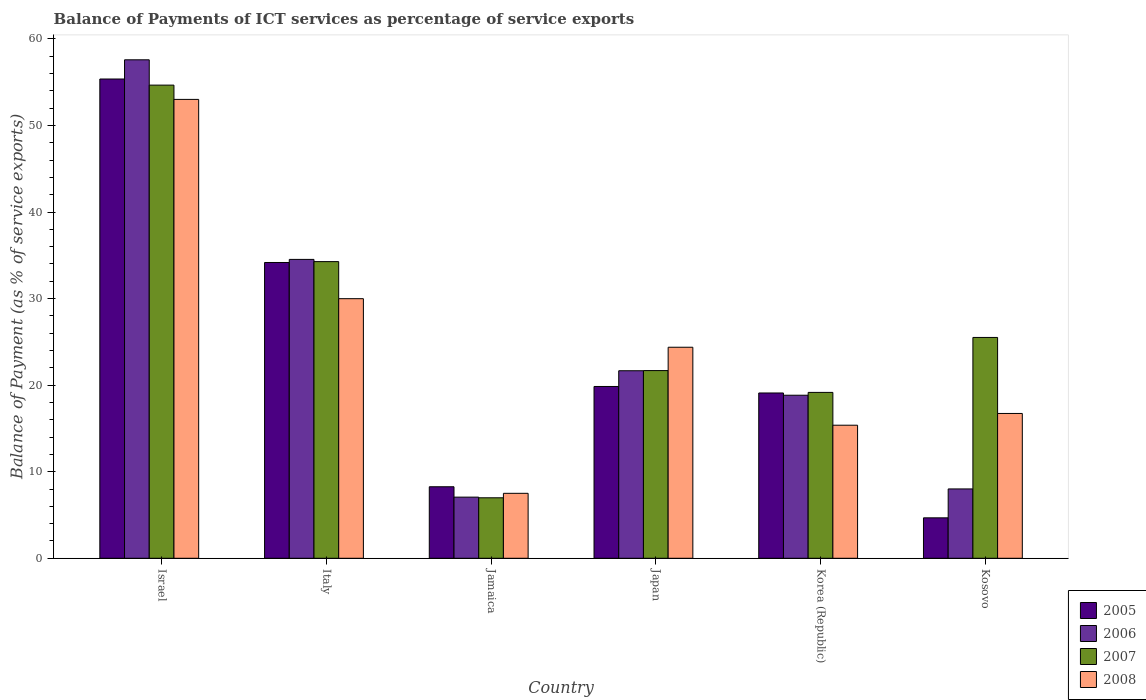How many groups of bars are there?
Keep it short and to the point. 6. Are the number of bars on each tick of the X-axis equal?
Your response must be concise. Yes. How many bars are there on the 1st tick from the left?
Offer a very short reply. 4. What is the label of the 6th group of bars from the left?
Provide a succinct answer. Kosovo. In how many cases, is the number of bars for a given country not equal to the number of legend labels?
Give a very brief answer. 0. What is the balance of payments of ICT services in 2005 in Kosovo?
Keep it short and to the point. 4.67. Across all countries, what is the maximum balance of payments of ICT services in 2005?
Your answer should be compact. 55.37. Across all countries, what is the minimum balance of payments of ICT services in 2006?
Make the answer very short. 7.06. In which country was the balance of payments of ICT services in 2007 minimum?
Provide a succinct answer. Jamaica. What is the total balance of payments of ICT services in 2006 in the graph?
Give a very brief answer. 147.7. What is the difference between the balance of payments of ICT services in 2007 in Jamaica and that in Korea (Republic)?
Give a very brief answer. -12.18. What is the difference between the balance of payments of ICT services in 2007 in Kosovo and the balance of payments of ICT services in 2006 in Korea (Republic)?
Offer a very short reply. 6.68. What is the average balance of payments of ICT services in 2008 per country?
Offer a very short reply. 24.5. What is the difference between the balance of payments of ICT services of/in 2007 and balance of payments of ICT services of/in 2006 in Italy?
Ensure brevity in your answer.  -0.26. In how many countries, is the balance of payments of ICT services in 2005 greater than 54 %?
Your answer should be compact. 1. What is the ratio of the balance of payments of ICT services in 2007 in Japan to that in Kosovo?
Your answer should be compact. 0.85. Is the difference between the balance of payments of ICT services in 2007 in Japan and Korea (Republic) greater than the difference between the balance of payments of ICT services in 2006 in Japan and Korea (Republic)?
Your response must be concise. No. What is the difference between the highest and the second highest balance of payments of ICT services in 2005?
Give a very brief answer. 14.33. What is the difference between the highest and the lowest balance of payments of ICT services in 2005?
Provide a succinct answer. 50.7. In how many countries, is the balance of payments of ICT services in 2006 greater than the average balance of payments of ICT services in 2006 taken over all countries?
Keep it short and to the point. 2. Is the sum of the balance of payments of ICT services in 2007 in Italy and Jamaica greater than the maximum balance of payments of ICT services in 2008 across all countries?
Offer a terse response. No. Is it the case that in every country, the sum of the balance of payments of ICT services in 2008 and balance of payments of ICT services in 2005 is greater than the sum of balance of payments of ICT services in 2006 and balance of payments of ICT services in 2007?
Offer a very short reply. No. What does the 4th bar from the left in Israel represents?
Provide a succinct answer. 2008. What does the 2nd bar from the right in Korea (Republic) represents?
Your response must be concise. 2007. Is it the case that in every country, the sum of the balance of payments of ICT services in 2006 and balance of payments of ICT services in 2007 is greater than the balance of payments of ICT services in 2008?
Provide a succinct answer. Yes. Are all the bars in the graph horizontal?
Your answer should be very brief. No. Are the values on the major ticks of Y-axis written in scientific E-notation?
Keep it short and to the point. No. Does the graph contain any zero values?
Offer a terse response. No. Where does the legend appear in the graph?
Give a very brief answer. Bottom right. What is the title of the graph?
Keep it short and to the point. Balance of Payments of ICT services as percentage of service exports. Does "2005" appear as one of the legend labels in the graph?
Offer a very short reply. Yes. What is the label or title of the X-axis?
Give a very brief answer. Country. What is the label or title of the Y-axis?
Provide a succinct answer. Balance of Payment (as % of service exports). What is the Balance of Payment (as % of service exports) of 2005 in Israel?
Offer a terse response. 55.37. What is the Balance of Payment (as % of service exports) of 2006 in Israel?
Ensure brevity in your answer.  57.59. What is the Balance of Payment (as % of service exports) of 2007 in Israel?
Provide a short and direct response. 54.67. What is the Balance of Payment (as % of service exports) in 2008 in Israel?
Your answer should be compact. 53.02. What is the Balance of Payment (as % of service exports) in 2005 in Italy?
Keep it short and to the point. 34.17. What is the Balance of Payment (as % of service exports) in 2006 in Italy?
Your answer should be very brief. 34.53. What is the Balance of Payment (as % of service exports) of 2007 in Italy?
Offer a terse response. 34.28. What is the Balance of Payment (as % of service exports) in 2008 in Italy?
Offer a terse response. 29.99. What is the Balance of Payment (as % of service exports) in 2005 in Jamaica?
Provide a succinct answer. 8.26. What is the Balance of Payment (as % of service exports) in 2006 in Jamaica?
Provide a succinct answer. 7.06. What is the Balance of Payment (as % of service exports) of 2007 in Jamaica?
Offer a very short reply. 6.99. What is the Balance of Payment (as % of service exports) of 2008 in Jamaica?
Offer a terse response. 7.5. What is the Balance of Payment (as % of service exports) in 2005 in Japan?
Your response must be concise. 19.85. What is the Balance of Payment (as % of service exports) in 2006 in Japan?
Your answer should be compact. 21.67. What is the Balance of Payment (as % of service exports) in 2007 in Japan?
Your response must be concise. 21.69. What is the Balance of Payment (as % of service exports) of 2008 in Japan?
Your answer should be very brief. 24.38. What is the Balance of Payment (as % of service exports) of 2005 in Korea (Republic)?
Your response must be concise. 19.1. What is the Balance of Payment (as % of service exports) of 2006 in Korea (Republic)?
Offer a terse response. 18.84. What is the Balance of Payment (as % of service exports) in 2007 in Korea (Republic)?
Ensure brevity in your answer.  19.16. What is the Balance of Payment (as % of service exports) in 2008 in Korea (Republic)?
Provide a short and direct response. 15.37. What is the Balance of Payment (as % of service exports) of 2005 in Kosovo?
Keep it short and to the point. 4.67. What is the Balance of Payment (as % of service exports) of 2006 in Kosovo?
Provide a short and direct response. 8.01. What is the Balance of Payment (as % of service exports) of 2007 in Kosovo?
Offer a very short reply. 25.51. What is the Balance of Payment (as % of service exports) of 2008 in Kosovo?
Give a very brief answer. 16.73. Across all countries, what is the maximum Balance of Payment (as % of service exports) in 2005?
Your response must be concise. 55.37. Across all countries, what is the maximum Balance of Payment (as % of service exports) in 2006?
Keep it short and to the point. 57.59. Across all countries, what is the maximum Balance of Payment (as % of service exports) of 2007?
Your answer should be very brief. 54.67. Across all countries, what is the maximum Balance of Payment (as % of service exports) in 2008?
Offer a terse response. 53.02. Across all countries, what is the minimum Balance of Payment (as % of service exports) in 2005?
Make the answer very short. 4.67. Across all countries, what is the minimum Balance of Payment (as % of service exports) in 2006?
Provide a succinct answer. 7.06. Across all countries, what is the minimum Balance of Payment (as % of service exports) of 2007?
Keep it short and to the point. 6.99. Across all countries, what is the minimum Balance of Payment (as % of service exports) in 2008?
Your response must be concise. 7.5. What is the total Balance of Payment (as % of service exports) of 2005 in the graph?
Keep it short and to the point. 141.43. What is the total Balance of Payment (as % of service exports) in 2006 in the graph?
Make the answer very short. 147.7. What is the total Balance of Payment (as % of service exports) of 2007 in the graph?
Offer a terse response. 162.29. What is the total Balance of Payment (as % of service exports) in 2008 in the graph?
Your response must be concise. 147. What is the difference between the Balance of Payment (as % of service exports) in 2005 in Israel and that in Italy?
Ensure brevity in your answer.  21.2. What is the difference between the Balance of Payment (as % of service exports) in 2006 in Israel and that in Italy?
Keep it short and to the point. 23.06. What is the difference between the Balance of Payment (as % of service exports) of 2007 in Israel and that in Italy?
Your answer should be very brief. 20.39. What is the difference between the Balance of Payment (as % of service exports) of 2008 in Israel and that in Italy?
Make the answer very short. 23.02. What is the difference between the Balance of Payment (as % of service exports) in 2005 in Israel and that in Jamaica?
Provide a succinct answer. 47.11. What is the difference between the Balance of Payment (as % of service exports) in 2006 in Israel and that in Jamaica?
Offer a very short reply. 50.53. What is the difference between the Balance of Payment (as % of service exports) in 2007 in Israel and that in Jamaica?
Give a very brief answer. 47.68. What is the difference between the Balance of Payment (as % of service exports) in 2008 in Israel and that in Jamaica?
Your response must be concise. 45.51. What is the difference between the Balance of Payment (as % of service exports) of 2005 in Israel and that in Japan?
Make the answer very short. 35.52. What is the difference between the Balance of Payment (as % of service exports) in 2006 in Israel and that in Japan?
Provide a short and direct response. 35.93. What is the difference between the Balance of Payment (as % of service exports) of 2007 in Israel and that in Japan?
Keep it short and to the point. 32.98. What is the difference between the Balance of Payment (as % of service exports) of 2008 in Israel and that in Japan?
Make the answer very short. 28.64. What is the difference between the Balance of Payment (as % of service exports) in 2005 in Israel and that in Korea (Republic)?
Provide a short and direct response. 36.28. What is the difference between the Balance of Payment (as % of service exports) of 2006 in Israel and that in Korea (Republic)?
Your answer should be compact. 38.75. What is the difference between the Balance of Payment (as % of service exports) of 2007 in Israel and that in Korea (Republic)?
Offer a very short reply. 35.5. What is the difference between the Balance of Payment (as % of service exports) of 2008 in Israel and that in Korea (Republic)?
Ensure brevity in your answer.  37.64. What is the difference between the Balance of Payment (as % of service exports) of 2005 in Israel and that in Kosovo?
Ensure brevity in your answer.  50.7. What is the difference between the Balance of Payment (as % of service exports) of 2006 in Israel and that in Kosovo?
Offer a terse response. 49.58. What is the difference between the Balance of Payment (as % of service exports) of 2007 in Israel and that in Kosovo?
Your answer should be compact. 29.15. What is the difference between the Balance of Payment (as % of service exports) in 2008 in Israel and that in Kosovo?
Make the answer very short. 36.29. What is the difference between the Balance of Payment (as % of service exports) in 2005 in Italy and that in Jamaica?
Your answer should be compact. 25.91. What is the difference between the Balance of Payment (as % of service exports) in 2006 in Italy and that in Jamaica?
Your answer should be compact. 27.47. What is the difference between the Balance of Payment (as % of service exports) of 2007 in Italy and that in Jamaica?
Your answer should be very brief. 27.29. What is the difference between the Balance of Payment (as % of service exports) in 2008 in Italy and that in Jamaica?
Make the answer very short. 22.49. What is the difference between the Balance of Payment (as % of service exports) of 2005 in Italy and that in Japan?
Provide a succinct answer. 14.33. What is the difference between the Balance of Payment (as % of service exports) of 2006 in Italy and that in Japan?
Your answer should be compact. 12.87. What is the difference between the Balance of Payment (as % of service exports) of 2007 in Italy and that in Japan?
Your answer should be very brief. 12.59. What is the difference between the Balance of Payment (as % of service exports) of 2008 in Italy and that in Japan?
Offer a very short reply. 5.61. What is the difference between the Balance of Payment (as % of service exports) of 2005 in Italy and that in Korea (Republic)?
Make the answer very short. 15.08. What is the difference between the Balance of Payment (as % of service exports) of 2006 in Italy and that in Korea (Republic)?
Provide a short and direct response. 15.69. What is the difference between the Balance of Payment (as % of service exports) of 2007 in Italy and that in Korea (Republic)?
Offer a terse response. 15.11. What is the difference between the Balance of Payment (as % of service exports) of 2008 in Italy and that in Korea (Republic)?
Your answer should be very brief. 14.62. What is the difference between the Balance of Payment (as % of service exports) in 2005 in Italy and that in Kosovo?
Offer a terse response. 29.5. What is the difference between the Balance of Payment (as % of service exports) in 2006 in Italy and that in Kosovo?
Give a very brief answer. 26.52. What is the difference between the Balance of Payment (as % of service exports) in 2007 in Italy and that in Kosovo?
Provide a short and direct response. 8.76. What is the difference between the Balance of Payment (as % of service exports) in 2008 in Italy and that in Kosovo?
Offer a terse response. 13.26. What is the difference between the Balance of Payment (as % of service exports) in 2005 in Jamaica and that in Japan?
Your answer should be very brief. -11.59. What is the difference between the Balance of Payment (as % of service exports) in 2006 in Jamaica and that in Japan?
Your answer should be very brief. -14.6. What is the difference between the Balance of Payment (as % of service exports) of 2007 in Jamaica and that in Japan?
Provide a short and direct response. -14.7. What is the difference between the Balance of Payment (as % of service exports) in 2008 in Jamaica and that in Japan?
Provide a succinct answer. -16.88. What is the difference between the Balance of Payment (as % of service exports) in 2005 in Jamaica and that in Korea (Republic)?
Your answer should be compact. -10.83. What is the difference between the Balance of Payment (as % of service exports) in 2006 in Jamaica and that in Korea (Republic)?
Provide a short and direct response. -11.78. What is the difference between the Balance of Payment (as % of service exports) in 2007 in Jamaica and that in Korea (Republic)?
Provide a succinct answer. -12.18. What is the difference between the Balance of Payment (as % of service exports) of 2008 in Jamaica and that in Korea (Republic)?
Provide a succinct answer. -7.87. What is the difference between the Balance of Payment (as % of service exports) of 2005 in Jamaica and that in Kosovo?
Your response must be concise. 3.59. What is the difference between the Balance of Payment (as % of service exports) of 2006 in Jamaica and that in Kosovo?
Ensure brevity in your answer.  -0.95. What is the difference between the Balance of Payment (as % of service exports) in 2007 in Jamaica and that in Kosovo?
Offer a very short reply. -18.53. What is the difference between the Balance of Payment (as % of service exports) in 2008 in Jamaica and that in Kosovo?
Offer a terse response. -9.23. What is the difference between the Balance of Payment (as % of service exports) in 2005 in Japan and that in Korea (Republic)?
Your answer should be very brief. 0.75. What is the difference between the Balance of Payment (as % of service exports) of 2006 in Japan and that in Korea (Republic)?
Your answer should be very brief. 2.83. What is the difference between the Balance of Payment (as % of service exports) of 2007 in Japan and that in Korea (Republic)?
Give a very brief answer. 2.52. What is the difference between the Balance of Payment (as % of service exports) of 2008 in Japan and that in Korea (Republic)?
Offer a terse response. 9.01. What is the difference between the Balance of Payment (as % of service exports) in 2005 in Japan and that in Kosovo?
Provide a short and direct response. 15.18. What is the difference between the Balance of Payment (as % of service exports) in 2006 in Japan and that in Kosovo?
Make the answer very short. 13.66. What is the difference between the Balance of Payment (as % of service exports) in 2007 in Japan and that in Kosovo?
Offer a very short reply. -3.83. What is the difference between the Balance of Payment (as % of service exports) in 2008 in Japan and that in Kosovo?
Provide a short and direct response. 7.65. What is the difference between the Balance of Payment (as % of service exports) of 2005 in Korea (Republic) and that in Kosovo?
Your answer should be compact. 14.43. What is the difference between the Balance of Payment (as % of service exports) in 2006 in Korea (Republic) and that in Kosovo?
Your response must be concise. 10.83. What is the difference between the Balance of Payment (as % of service exports) of 2007 in Korea (Republic) and that in Kosovo?
Offer a terse response. -6.35. What is the difference between the Balance of Payment (as % of service exports) in 2008 in Korea (Republic) and that in Kosovo?
Give a very brief answer. -1.36. What is the difference between the Balance of Payment (as % of service exports) in 2005 in Israel and the Balance of Payment (as % of service exports) in 2006 in Italy?
Give a very brief answer. 20.84. What is the difference between the Balance of Payment (as % of service exports) of 2005 in Israel and the Balance of Payment (as % of service exports) of 2007 in Italy?
Keep it short and to the point. 21.1. What is the difference between the Balance of Payment (as % of service exports) of 2005 in Israel and the Balance of Payment (as % of service exports) of 2008 in Italy?
Provide a succinct answer. 25.38. What is the difference between the Balance of Payment (as % of service exports) of 2006 in Israel and the Balance of Payment (as % of service exports) of 2007 in Italy?
Offer a very short reply. 23.32. What is the difference between the Balance of Payment (as % of service exports) of 2006 in Israel and the Balance of Payment (as % of service exports) of 2008 in Italy?
Your answer should be very brief. 27.6. What is the difference between the Balance of Payment (as % of service exports) in 2007 in Israel and the Balance of Payment (as % of service exports) in 2008 in Italy?
Your response must be concise. 24.67. What is the difference between the Balance of Payment (as % of service exports) of 2005 in Israel and the Balance of Payment (as % of service exports) of 2006 in Jamaica?
Provide a succinct answer. 48.31. What is the difference between the Balance of Payment (as % of service exports) of 2005 in Israel and the Balance of Payment (as % of service exports) of 2007 in Jamaica?
Make the answer very short. 48.39. What is the difference between the Balance of Payment (as % of service exports) of 2005 in Israel and the Balance of Payment (as % of service exports) of 2008 in Jamaica?
Ensure brevity in your answer.  47.87. What is the difference between the Balance of Payment (as % of service exports) in 2006 in Israel and the Balance of Payment (as % of service exports) in 2007 in Jamaica?
Your answer should be compact. 50.61. What is the difference between the Balance of Payment (as % of service exports) in 2006 in Israel and the Balance of Payment (as % of service exports) in 2008 in Jamaica?
Give a very brief answer. 50.09. What is the difference between the Balance of Payment (as % of service exports) in 2007 in Israel and the Balance of Payment (as % of service exports) in 2008 in Jamaica?
Offer a terse response. 47.16. What is the difference between the Balance of Payment (as % of service exports) in 2005 in Israel and the Balance of Payment (as % of service exports) in 2006 in Japan?
Offer a very short reply. 33.71. What is the difference between the Balance of Payment (as % of service exports) of 2005 in Israel and the Balance of Payment (as % of service exports) of 2007 in Japan?
Provide a succinct answer. 33.69. What is the difference between the Balance of Payment (as % of service exports) of 2005 in Israel and the Balance of Payment (as % of service exports) of 2008 in Japan?
Ensure brevity in your answer.  30.99. What is the difference between the Balance of Payment (as % of service exports) of 2006 in Israel and the Balance of Payment (as % of service exports) of 2007 in Japan?
Give a very brief answer. 35.91. What is the difference between the Balance of Payment (as % of service exports) in 2006 in Israel and the Balance of Payment (as % of service exports) in 2008 in Japan?
Give a very brief answer. 33.21. What is the difference between the Balance of Payment (as % of service exports) in 2007 in Israel and the Balance of Payment (as % of service exports) in 2008 in Japan?
Offer a very short reply. 30.28. What is the difference between the Balance of Payment (as % of service exports) of 2005 in Israel and the Balance of Payment (as % of service exports) of 2006 in Korea (Republic)?
Give a very brief answer. 36.53. What is the difference between the Balance of Payment (as % of service exports) of 2005 in Israel and the Balance of Payment (as % of service exports) of 2007 in Korea (Republic)?
Give a very brief answer. 36.21. What is the difference between the Balance of Payment (as % of service exports) of 2005 in Israel and the Balance of Payment (as % of service exports) of 2008 in Korea (Republic)?
Provide a short and direct response. 40. What is the difference between the Balance of Payment (as % of service exports) in 2006 in Israel and the Balance of Payment (as % of service exports) in 2007 in Korea (Republic)?
Your answer should be very brief. 38.43. What is the difference between the Balance of Payment (as % of service exports) of 2006 in Israel and the Balance of Payment (as % of service exports) of 2008 in Korea (Republic)?
Your answer should be very brief. 42.22. What is the difference between the Balance of Payment (as % of service exports) in 2007 in Israel and the Balance of Payment (as % of service exports) in 2008 in Korea (Republic)?
Keep it short and to the point. 39.29. What is the difference between the Balance of Payment (as % of service exports) of 2005 in Israel and the Balance of Payment (as % of service exports) of 2006 in Kosovo?
Offer a terse response. 47.36. What is the difference between the Balance of Payment (as % of service exports) in 2005 in Israel and the Balance of Payment (as % of service exports) in 2007 in Kosovo?
Your answer should be compact. 29.86. What is the difference between the Balance of Payment (as % of service exports) of 2005 in Israel and the Balance of Payment (as % of service exports) of 2008 in Kosovo?
Keep it short and to the point. 38.64. What is the difference between the Balance of Payment (as % of service exports) in 2006 in Israel and the Balance of Payment (as % of service exports) in 2007 in Kosovo?
Offer a terse response. 32.08. What is the difference between the Balance of Payment (as % of service exports) in 2006 in Israel and the Balance of Payment (as % of service exports) in 2008 in Kosovo?
Make the answer very short. 40.86. What is the difference between the Balance of Payment (as % of service exports) of 2007 in Israel and the Balance of Payment (as % of service exports) of 2008 in Kosovo?
Your answer should be very brief. 37.94. What is the difference between the Balance of Payment (as % of service exports) of 2005 in Italy and the Balance of Payment (as % of service exports) of 2006 in Jamaica?
Offer a terse response. 27.11. What is the difference between the Balance of Payment (as % of service exports) of 2005 in Italy and the Balance of Payment (as % of service exports) of 2007 in Jamaica?
Make the answer very short. 27.19. What is the difference between the Balance of Payment (as % of service exports) in 2005 in Italy and the Balance of Payment (as % of service exports) in 2008 in Jamaica?
Your answer should be very brief. 26.67. What is the difference between the Balance of Payment (as % of service exports) in 2006 in Italy and the Balance of Payment (as % of service exports) in 2007 in Jamaica?
Make the answer very short. 27.54. What is the difference between the Balance of Payment (as % of service exports) in 2006 in Italy and the Balance of Payment (as % of service exports) in 2008 in Jamaica?
Offer a very short reply. 27.03. What is the difference between the Balance of Payment (as % of service exports) in 2007 in Italy and the Balance of Payment (as % of service exports) in 2008 in Jamaica?
Make the answer very short. 26.77. What is the difference between the Balance of Payment (as % of service exports) of 2005 in Italy and the Balance of Payment (as % of service exports) of 2006 in Japan?
Your response must be concise. 12.51. What is the difference between the Balance of Payment (as % of service exports) in 2005 in Italy and the Balance of Payment (as % of service exports) in 2007 in Japan?
Your response must be concise. 12.49. What is the difference between the Balance of Payment (as % of service exports) of 2005 in Italy and the Balance of Payment (as % of service exports) of 2008 in Japan?
Your answer should be compact. 9.79. What is the difference between the Balance of Payment (as % of service exports) of 2006 in Italy and the Balance of Payment (as % of service exports) of 2007 in Japan?
Keep it short and to the point. 12.85. What is the difference between the Balance of Payment (as % of service exports) of 2006 in Italy and the Balance of Payment (as % of service exports) of 2008 in Japan?
Provide a succinct answer. 10.15. What is the difference between the Balance of Payment (as % of service exports) in 2007 in Italy and the Balance of Payment (as % of service exports) in 2008 in Japan?
Provide a succinct answer. 9.89. What is the difference between the Balance of Payment (as % of service exports) in 2005 in Italy and the Balance of Payment (as % of service exports) in 2006 in Korea (Republic)?
Your answer should be compact. 15.34. What is the difference between the Balance of Payment (as % of service exports) of 2005 in Italy and the Balance of Payment (as % of service exports) of 2007 in Korea (Republic)?
Offer a terse response. 15.01. What is the difference between the Balance of Payment (as % of service exports) in 2005 in Italy and the Balance of Payment (as % of service exports) in 2008 in Korea (Republic)?
Provide a short and direct response. 18.8. What is the difference between the Balance of Payment (as % of service exports) of 2006 in Italy and the Balance of Payment (as % of service exports) of 2007 in Korea (Republic)?
Your response must be concise. 15.37. What is the difference between the Balance of Payment (as % of service exports) in 2006 in Italy and the Balance of Payment (as % of service exports) in 2008 in Korea (Republic)?
Offer a terse response. 19.16. What is the difference between the Balance of Payment (as % of service exports) in 2007 in Italy and the Balance of Payment (as % of service exports) in 2008 in Korea (Republic)?
Your response must be concise. 18.9. What is the difference between the Balance of Payment (as % of service exports) in 2005 in Italy and the Balance of Payment (as % of service exports) in 2006 in Kosovo?
Keep it short and to the point. 26.16. What is the difference between the Balance of Payment (as % of service exports) in 2005 in Italy and the Balance of Payment (as % of service exports) in 2007 in Kosovo?
Ensure brevity in your answer.  8.66. What is the difference between the Balance of Payment (as % of service exports) in 2005 in Italy and the Balance of Payment (as % of service exports) in 2008 in Kosovo?
Provide a succinct answer. 17.44. What is the difference between the Balance of Payment (as % of service exports) of 2006 in Italy and the Balance of Payment (as % of service exports) of 2007 in Kosovo?
Make the answer very short. 9.02. What is the difference between the Balance of Payment (as % of service exports) in 2006 in Italy and the Balance of Payment (as % of service exports) in 2008 in Kosovo?
Offer a terse response. 17.8. What is the difference between the Balance of Payment (as % of service exports) of 2007 in Italy and the Balance of Payment (as % of service exports) of 2008 in Kosovo?
Make the answer very short. 17.54. What is the difference between the Balance of Payment (as % of service exports) in 2005 in Jamaica and the Balance of Payment (as % of service exports) in 2006 in Japan?
Give a very brief answer. -13.4. What is the difference between the Balance of Payment (as % of service exports) in 2005 in Jamaica and the Balance of Payment (as % of service exports) in 2007 in Japan?
Keep it short and to the point. -13.42. What is the difference between the Balance of Payment (as % of service exports) of 2005 in Jamaica and the Balance of Payment (as % of service exports) of 2008 in Japan?
Ensure brevity in your answer.  -16.12. What is the difference between the Balance of Payment (as % of service exports) in 2006 in Jamaica and the Balance of Payment (as % of service exports) in 2007 in Japan?
Ensure brevity in your answer.  -14.62. What is the difference between the Balance of Payment (as % of service exports) of 2006 in Jamaica and the Balance of Payment (as % of service exports) of 2008 in Japan?
Give a very brief answer. -17.32. What is the difference between the Balance of Payment (as % of service exports) of 2007 in Jamaica and the Balance of Payment (as % of service exports) of 2008 in Japan?
Offer a very short reply. -17.39. What is the difference between the Balance of Payment (as % of service exports) of 2005 in Jamaica and the Balance of Payment (as % of service exports) of 2006 in Korea (Republic)?
Ensure brevity in your answer.  -10.58. What is the difference between the Balance of Payment (as % of service exports) in 2005 in Jamaica and the Balance of Payment (as % of service exports) in 2007 in Korea (Republic)?
Make the answer very short. -10.9. What is the difference between the Balance of Payment (as % of service exports) of 2005 in Jamaica and the Balance of Payment (as % of service exports) of 2008 in Korea (Republic)?
Make the answer very short. -7.11. What is the difference between the Balance of Payment (as % of service exports) in 2006 in Jamaica and the Balance of Payment (as % of service exports) in 2007 in Korea (Republic)?
Offer a very short reply. -12.1. What is the difference between the Balance of Payment (as % of service exports) of 2006 in Jamaica and the Balance of Payment (as % of service exports) of 2008 in Korea (Republic)?
Offer a very short reply. -8.31. What is the difference between the Balance of Payment (as % of service exports) in 2007 in Jamaica and the Balance of Payment (as % of service exports) in 2008 in Korea (Republic)?
Make the answer very short. -8.39. What is the difference between the Balance of Payment (as % of service exports) of 2005 in Jamaica and the Balance of Payment (as % of service exports) of 2006 in Kosovo?
Make the answer very short. 0.25. What is the difference between the Balance of Payment (as % of service exports) of 2005 in Jamaica and the Balance of Payment (as % of service exports) of 2007 in Kosovo?
Provide a succinct answer. -17.25. What is the difference between the Balance of Payment (as % of service exports) of 2005 in Jamaica and the Balance of Payment (as % of service exports) of 2008 in Kosovo?
Offer a terse response. -8.47. What is the difference between the Balance of Payment (as % of service exports) in 2006 in Jamaica and the Balance of Payment (as % of service exports) in 2007 in Kosovo?
Your response must be concise. -18.45. What is the difference between the Balance of Payment (as % of service exports) of 2006 in Jamaica and the Balance of Payment (as % of service exports) of 2008 in Kosovo?
Provide a short and direct response. -9.67. What is the difference between the Balance of Payment (as % of service exports) in 2007 in Jamaica and the Balance of Payment (as % of service exports) in 2008 in Kosovo?
Give a very brief answer. -9.74. What is the difference between the Balance of Payment (as % of service exports) of 2005 in Japan and the Balance of Payment (as % of service exports) of 2006 in Korea (Republic)?
Offer a very short reply. 1.01. What is the difference between the Balance of Payment (as % of service exports) of 2005 in Japan and the Balance of Payment (as % of service exports) of 2007 in Korea (Republic)?
Give a very brief answer. 0.68. What is the difference between the Balance of Payment (as % of service exports) in 2005 in Japan and the Balance of Payment (as % of service exports) in 2008 in Korea (Republic)?
Give a very brief answer. 4.48. What is the difference between the Balance of Payment (as % of service exports) of 2006 in Japan and the Balance of Payment (as % of service exports) of 2007 in Korea (Republic)?
Your response must be concise. 2.5. What is the difference between the Balance of Payment (as % of service exports) in 2006 in Japan and the Balance of Payment (as % of service exports) in 2008 in Korea (Republic)?
Ensure brevity in your answer.  6.29. What is the difference between the Balance of Payment (as % of service exports) of 2007 in Japan and the Balance of Payment (as % of service exports) of 2008 in Korea (Republic)?
Your response must be concise. 6.31. What is the difference between the Balance of Payment (as % of service exports) of 2005 in Japan and the Balance of Payment (as % of service exports) of 2006 in Kosovo?
Your response must be concise. 11.84. What is the difference between the Balance of Payment (as % of service exports) in 2005 in Japan and the Balance of Payment (as % of service exports) in 2007 in Kosovo?
Provide a succinct answer. -5.67. What is the difference between the Balance of Payment (as % of service exports) in 2005 in Japan and the Balance of Payment (as % of service exports) in 2008 in Kosovo?
Ensure brevity in your answer.  3.12. What is the difference between the Balance of Payment (as % of service exports) in 2006 in Japan and the Balance of Payment (as % of service exports) in 2007 in Kosovo?
Provide a succinct answer. -3.85. What is the difference between the Balance of Payment (as % of service exports) in 2006 in Japan and the Balance of Payment (as % of service exports) in 2008 in Kosovo?
Your answer should be very brief. 4.93. What is the difference between the Balance of Payment (as % of service exports) of 2007 in Japan and the Balance of Payment (as % of service exports) of 2008 in Kosovo?
Your answer should be very brief. 4.95. What is the difference between the Balance of Payment (as % of service exports) of 2005 in Korea (Republic) and the Balance of Payment (as % of service exports) of 2006 in Kosovo?
Give a very brief answer. 11.09. What is the difference between the Balance of Payment (as % of service exports) in 2005 in Korea (Republic) and the Balance of Payment (as % of service exports) in 2007 in Kosovo?
Provide a succinct answer. -6.42. What is the difference between the Balance of Payment (as % of service exports) in 2005 in Korea (Republic) and the Balance of Payment (as % of service exports) in 2008 in Kosovo?
Provide a succinct answer. 2.37. What is the difference between the Balance of Payment (as % of service exports) in 2006 in Korea (Republic) and the Balance of Payment (as % of service exports) in 2007 in Kosovo?
Keep it short and to the point. -6.68. What is the difference between the Balance of Payment (as % of service exports) in 2006 in Korea (Republic) and the Balance of Payment (as % of service exports) in 2008 in Kosovo?
Ensure brevity in your answer.  2.11. What is the difference between the Balance of Payment (as % of service exports) in 2007 in Korea (Republic) and the Balance of Payment (as % of service exports) in 2008 in Kosovo?
Your response must be concise. 2.43. What is the average Balance of Payment (as % of service exports) of 2005 per country?
Ensure brevity in your answer.  23.57. What is the average Balance of Payment (as % of service exports) of 2006 per country?
Your answer should be very brief. 24.62. What is the average Balance of Payment (as % of service exports) of 2007 per country?
Your answer should be compact. 27.05. What is the average Balance of Payment (as % of service exports) of 2008 per country?
Make the answer very short. 24.5. What is the difference between the Balance of Payment (as % of service exports) of 2005 and Balance of Payment (as % of service exports) of 2006 in Israel?
Make the answer very short. -2.22. What is the difference between the Balance of Payment (as % of service exports) in 2005 and Balance of Payment (as % of service exports) in 2007 in Israel?
Your response must be concise. 0.71. What is the difference between the Balance of Payment (as % of service exports) of 2005 and Balance of Payment (as % of service exports) of 2008 in Israel?
Give a very brief answer. 2.36. What is the difference between the Balance of Payment (as % of service exports) in 2006 and Balance of Payment (as % of service exports) in 2007 in Israel?
Keep it short and to the point. 2.93. What is the difference between the Balance of Payment (as % of service exports) of 2006 and Balance of Payment (as % of service exports) of 2008 in Israel?
Your response must be concise. 4.57. What is the difference between the Balance of Payment (as % of service exports) of 2007 and Balance of Payment (as % of service exports) of 2008 in Israel?
Your answer should be compact. 1.65. What is the difference between the Balance of Payment (as % of service exports) in 2005 and Balance of Payment (as % of service exports) in 2006 in Italy?
Ensure brevity in your answer.  -0.36. What is the difference between the Balance of Payment (as % of service exports) in 2005 and Balance of Payment (as % of service exports) in 2007 in Italy?
Your response must be concise. -0.1. What is the difference between the Balance of Payment (as % of service exports) in 2005 and Balance of Payment (as % of service exports) in 2008 in Italy?
Offer a terse response. 4.18. What is the difference between the Balance of Payment (as % of service exports) of 2006 and Balance of Payment (as % of service exports) of 2007 in Italy?
Offer a terse response. 0.26. What is the difference between the Balance of Payment (as % of service exports) in 2006 and Balance of Payment (as % of service exports) in 2008 in Italy?
Your response must be concise. 4.54. What is the difference between the Balance of Payment (as % of service exports) in 2007 and Balance of Payment (as % of service exports) in 2008 in Italy?
Your response must be concise. 4.28. What is the difference between the Balance of Payment (as % of service exports) of 2005 and Balance of Payment (as % of service exports) of 2006 in Jamaica?
Provide a short and direct response. 1.2. What is the difference between the Balance of Payment (as % of service exports) in 2005 and Balance of Payment (as % of service exports) in 2007 in Jamaica?
Give a very brief answer. 1.28. What is the difference between the Balance of Payment (as % of service exports) of 2005 and Balance of Payment (as % of service exports) of 2008 in Jamaica?
Offer a very short reply. 0.76. What is the difference between the Balance of Payment (as % of service exports) in 2006 and Balance of Payment (as % of service exports) in 2007 in Jamaica?
Your answer should be very brief. 0.08. What is the difference between the Balance of Payment (as % of service exports) of 2006 and Balance of Payment (as % of service exports) of 2008 in Jamaica?
Give a very brief answer. -0.44. What is the difference between the Balance of Payment (as % of service exports) in 2007 and Balance of Payment (as % of service exports) in 2008 in Jamaica?
Make the answer very short. -0.52. What is the difference between the Balance of Payment (as % of service exports) of 2005 and Balance of Payment (as % of service exports) of 2006 in Japan?
Give a very brief answer. -1.82. What is the difference between the Balance of Payment (as % of service exports) in 2005 and Balance of Payment (as % of service exports) in 2007 in Japan?
Offer a very short reply. -1.84. What is the difference between the Balance of Payment (as % of service exports) in 2005 and Balance of Payment (as % of service exports) in 2008 in Japan?
Ensure brevity in your answer.  -4.53. What is the difference between the Balance of Payment (as % of service exports) in 2006 and Balance of Payment (as % of service exports) in 2007 in Japan?
Offer a terse response. -0.02. What is the difference between the Balance of Payment (as % of service exports) of 2006 and Balance of Payment (as % of service exports) of 2008 in Japan?
Offer a terse response. -2.72. What is the difference between the Balance of Payment (as % of service exports) in 2007 and Balance of Payment (as % of service exports) in 2008 in Japan?
Offer a terse response. -2.7. What is the difference between the Balance of Payment (as % of service exports) of 2005 and Balance of Payment (as % of service exports) of 2006 in Korea (Republic)?
Keep it short and to the point. 0.26. What is the difference between the Balance of Payment (as % of service exports) in 2005 and Balance of Payment (as % of service exports) in 2007 in Korea (Republic)?
Provide a succinct answer. -0.07. What is the difference between the Balance of Payment (as % of service exports) in 2005 and Balance of Payment (as % of service exports) in 2008 in Korea (Republic)?
Give a very brief answer. 3.72. What is the difference between the Balance of Payment (as % of service exports) in 2006 and Balance of Payment (as % of service exports) in 2007 in Korea (Republic)?
Offer a very short reply. -0.33. What is the difference between the Balance of Payment (as % of service exports) of 2006 and Balance of Payment (as % of service exports) of 2008 in Korea (Republic)?
Provide a succinct answer. 3.46. What is the difference between the Balance of Payment (as % of service exports) of 2007 and Balance of Payment (as % of service exports) of 2008 in Korea (Republic)?
Offer a very short reply. 3.79. What is the difference between the Balance of Payment (as % of service exports) of 2005 and Balance of Payment (as % of service exports) of 2006 in Kosovo?
Make the answer very short. -3.34. What is the difference between the Balance of Payment (as % of service exports) in 2005 and Balance of Payment (as % of service exports) in 2007 in Kosovo?
Ensure brevity in your answer.  -20.84. What is the difference between the Balance of Payment (as % of service exports) in 2005 and Balance of Payment (as % of service exports) in 2008 in Kosovo?
Your answer should be compact. -12.06. What is the difference between the Balance of Payment (as % of service exports) in 2006 and Balance of Payment (as % of service exports) in 2007 in Kosovo?
Give a very brief answer. -17.5. What is the difference between the Balance of Payment (as % of service exports) of 2006 and Balance of Payment (as % of service exports) of 2008 in Kosovo?
Provide a succinct answer. -8.72. What is the difference between the Balance of Payment (as % of service exports) of 2007 and Balance of Payment (as % of service exports) of 2008 in Kosovo?
Your answer should be compact. 8.78. What is the ratio of the Balance of Payment (as % of service exports) of 2005 in Israel to that in Italy?
Ensure brevity in your answer.  1.62. What is the ratio of the Balance of Payment (as % of service exports) of 2006 in Israel to that in Italy?
Offer a terse response. 1.67. What is the ratio of the Balance of Payment (as % of service exports) of 2007 in Israel to that in Italy?
Your answer should be very brief. 1.59. What is the ratio of the Balance of Payment (as % of service exports) in 2008 in Israel to that in Italy?
Your answer should be very brief. 1.77. What is the ratio of the Balance of Payment (as % of service exports) in 2005 in Israel to that in Jamaica?
Give a very brief answer. 6.7. What is the ratio of the Balance of Payment (as % of service exports) of 2006 in Israel to that in Jamaica?
Give a very brief answer. 8.15. What is the ratio of the Balance of Payment (as % of service exports) in 2007 in Israel to that in Jamaica?
Your answer should be compact. 7.82. What is the ratio of the Balance of Payment (as % of service exports) in 2008 in Israel to that in Jamaica?
Offer a very short reply. 7.07. What is the ratio of the Balance of Payment (as % of service exports) of 2005 in Israel to that in Japan?
Make the answer very short. 2.79. What is the ratio of the Balance of Payment (as % of service exports) in 2006 in Israel to that in Japan?
Provide a succinct answer. 2.66. What is the ratio of the Balance of Payment (as % of service exports) in 2007 in Israel to that in Japan?
Ensure brevity in your answer.  2.52. What is the ratio of the Balance of Payment (as % of service exports) of 2008 in Israel to that in Japan?
Your answer should be compact. 2.17. What is the ratio of the Balance of Payment (as % of service exports) in 2005 in Israel to that in Korea (Republic)?
Offer a terse response. 2.9. What is the ratio of the Balance of Payment (as % of service exports) in 2006 in Israel to that in Korea (Republic)?
Make the answer very short. 3.06. What is the ratio of the Balance of Payment (as % of service exports) of 2007 in Israel to that in Korea (Republic)?
Provide a short and direct response. 2.85. What is the ratio of the Balance of Payment (as % of service exports) in 2008 in Israel to that in Korea (Republic)?
Make the answer very short. 3.45. What is the ratio of the Balance of Payment (as % of service exports) of 2005 in Israel to that in Kosovo?
Your response must be concise. 11.85. What is the ratio of the Balance of Payment (as % of service exports) in 2006 in Israel to that in Kosovo?
Your answer should be very brief. 7.19. What is the ratio of the Balance of Payment (as % of service exports) of 2007 in Israel to that in Kosovo?
Your answer should be very brief. 2.14. What is the ratio of the Balance of Payment (as % of service exports) in 2008 in Israel to that in Kosovo?
Ensure brevity in your answer.  3.17. What is the ratio of the Balance of Payment (as % of service exports) of 2005 in Italy to that in Jamaica?
Offer a terse response. 4.14. What is the ratio of the Balance of Payment (as % of service exports) of 2006 in Italy to that in Jamaica?
Keep it short and to the point. 4.89. What is the ratio of the Balance of Payment (as % of service exports) in 2007 in Italy to that in Jamaica?
Provide a short and direct response. 4.91. What is the ratio of the Balance of Payment (as % of service exports) in 2008 in Italy to that in Jamaica?
Provide a succinct answer. 4. What is the ratio of the Balance of Payment (as % of service exports) of 2005 in Italy to that in Japan?
Your answer should be compact. 1.72. What is the ratio of the Balance of Payment (as % of service exports) of 2006 in Italy to that in Japan?
Your response must be concise. 1.59. What is the ratio of the Balance of Payment (as % of service exports) in 2007 in Italy to that in Japan?
Make the answer very short. 1.58. What is the ratio of the Balance of Payment (as % of service exports) in 2008 in Italy to that in Japan?
Offer a very short reply. 1.23. What is the ratio of the Balance of Payment (as % of service exports) of 2005 in Italy to that in Korea (Republic)?
Offer a terse response. 1.79. What is the ratio of the Balance of Payment (as % of service exports) of 2006 in Italy to that in Korea (Republic)?
Your answer should be very brief. 1.83. What is the ratio of the Balance of Payment (as % of service exports) of 2007 in Italy to that in Korea (Republic)?
Your answer should be very brief. 1.79. What is the ratio of the Balance of Payment (as % of service exports) of 2008 in Italy to that in Korea (Republic)?
Provide a succinct answer. 1.95. What is the ratio of the Balance of Payment (as % of service exports) in 2005 in Italy to that in Kosovo?
Offer a very short reply. 7.32. What is the ratio of the Balance of Payment (as % of service exports) in 2006 in Italy to that in Kosovo?
Ensure brevity in your answer.  4.31. What is the ratio of the Balance of Payment (as % of service exports) of 2007 in Italy to that in Kosovo?
Ensure brevity in your answer.  1.34. What is the ratio of the Balance of Payment (as % of service exports) in 2008 in Italy to that in Kosovo?
Offer a very short reply. 1.79. What is the ratio of the Balance of Payment (as % of service exports) of 2005 in Jamaica to that in Japan?
Keep it short and to the point. 0.42. What is the ratio of the Balance of Payment (as % of service exports) of 2006 in Jamaica to that in Japan?
Offer a terse response. 0.33. What is the ratio of the Balance of Payment (as % of service exports) of 2007 in Jamaica to that in Japan?
Your response must be concise. 0.32. What is the ratio of the Balance of Payment (as % of service exports) in 2008 in Jamaica to that in Japan?
Ensure brevity in your answer.  0.31. What is the ratio of the Balance of Payment (as % of service exports) in 2005 in Jamaica to that in Korea (Republic)?
Make the answer very short. 0.43. What is the ratio of the Balance of Payment (as % of service exports) in 2006 in Jamaica to that in Korea (Republic)?
Your answer should be compact. 0.37. What is the ratio of the Balance of Payment (as % of service exports) in 2007 in Jamaica to that in Korea (Republic)?
Provide a succinct answer. 0.36. What is the ratio of the Balance of Payment (as % of service exports) of 2008 in Jamaica to that in Korea (Republic)?
Ensure brevity in your answer.  0.49. What is the ratio of the Balance of Payment (as % of service exports) of 2005 in Jamaica to that in Kosovo?
Provide a short and direct response. 1.77. What is the ratio of the Balance of Payment (as % of service exports) of 2006 in Jamaica to that in Kosovo?
Ensure brevity in your answer.  0.88. What is the ratio of the Balance of Payment (as % of service exports) of 2007 in Jamaica to that in Kosovo?
Offer a very short reply. 0.27. What is the ratio of the Balance of Payment (as % of service exports) in 2008 in Jamaica to that in Kosovo?
Your response must be concise. 0.45. What is the ratio of the Balance of Payment (as % of service exports) in 2005 in Japan to that in Korea (Republic)?
Provide a short and direct response. 1.04. What is the ratio of the Balance of Payment (as % of service exports) of 2006 in Japan to that in Korea (Republic)?
Ensure brevity in your answer.  1.15. What is the ratio of the Balance of Payment (as % of service exports) in 2007 in Japan to that in Korea (Republic)?
Your answer should be very brief. 1.13. What is the ratio of the Balance of Payment (as % of service exports) in 2008 in Japan to that in Korea (Republic)?
Provide a succinct answer. 1.59. What is the ratio of the Balance of Payment (as % of service exports) in 2005 in Japan to that in Kosovo?
Your answer should be compact. 4.25. What is the ratio of the Balance of Payment (as % of service exports) of 2006 in Japan to that in Kosovo?
Offer a very short reply. 2.7. What is the ratio of the Balance of Payment (as % of service exports) in 2007 in Japan to that in Kosovo?
Provide a succinct answer. 0.85. What is the ratio of the Balance of Payment (as % of service exports) of 2008 in Japan to that in Kosovo?
Offer a terse response. 1.46. What is the ratio of the Balance of Payment (as % of service exports) in 2005 in Korea (Republic) to that in Kosovo?
Ensure brevity in your answer.  4.09. What is the ratio of the Balance of Payment (as % of service exports) of 2006 in Korea (Republic) to that in Kosovo?
Provide a short and direct response. 2.35. What is the ratio of the Balance of Payment (as % of service exports) in 2007 in Korea (Republic) to that in Kosovo?
Your answer should be compact. 0.75. What is the ratio of the Balance of Payment (as % of service exports) of 2008 in Korea (Republic) to that in Kosovo?
Keep it short and to the point. 0.92. What is the difference between the highest and the second highest Balance of Payment (as % of service exports) of 2005?
Give a very brief answer. 21.2. What is the difference between the highest and the second highest Balance of Payment (as % of service exports) in 2006?
Give a very brief answer. 23.06. What is the difference between the highest and the second highest Balance of Payment (as % of service exports) in 2007?
Offer a terse response. 20.39. What is the difference between the highest and the second highest Balance of Payment (as % of service exports) in 2008?
Keep it short and to the point. 23.02. What is the difference between the highest and the lowest Balance of Payment (as % of service exports) in 2005?
Keep it short and to the point. 50.7. What is the difference between the highest and the lowest Balance of Payment (as % of service exports) of 2006?
Your answer should be compact. 50.53. What is the difference between the highest and the lowest Balance of Payment (as % of service exports) of 2007?
Your answer should be compact. 47.68. What is the difference between the highest and the lowest Balance of Payment (as % of service exports) of 2008?
Give a very brief answer. 45.51. 